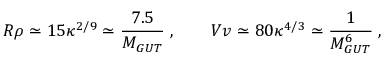<formula> <loc_0><loc_0><loc_500><loc_500>R \rho \simeq 1 5 \kappa ^ { 2 / 9 } \simeq \frac { 7 . 5 } { M _ { G U T } } \, , \quad V v \simeq 8 0 \kappa ^ { 4 / 3 } \simeq \frac { 1 } { M _ { G U T } ^ { 6 } } \, ,</formula> 